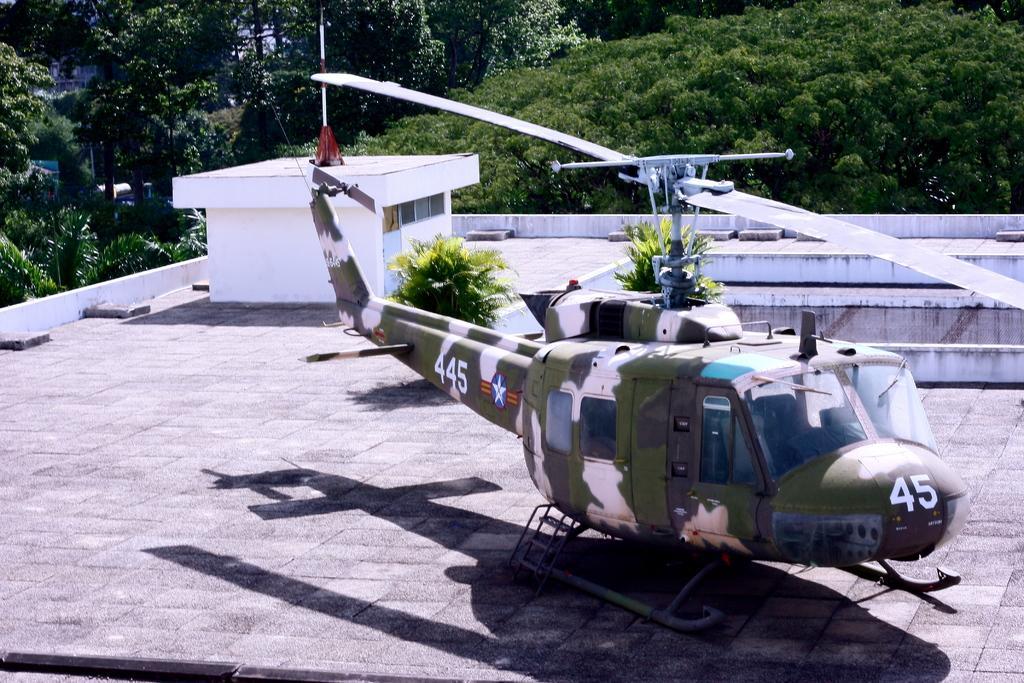Could you give a brief overview of what you see in this image? There is a helicopter on the roof top. There are plants on the rooftop. On the helicopter there is a logo and a number. In the back there are trees. And there is a room on the rooftop. On that there is a pole. 